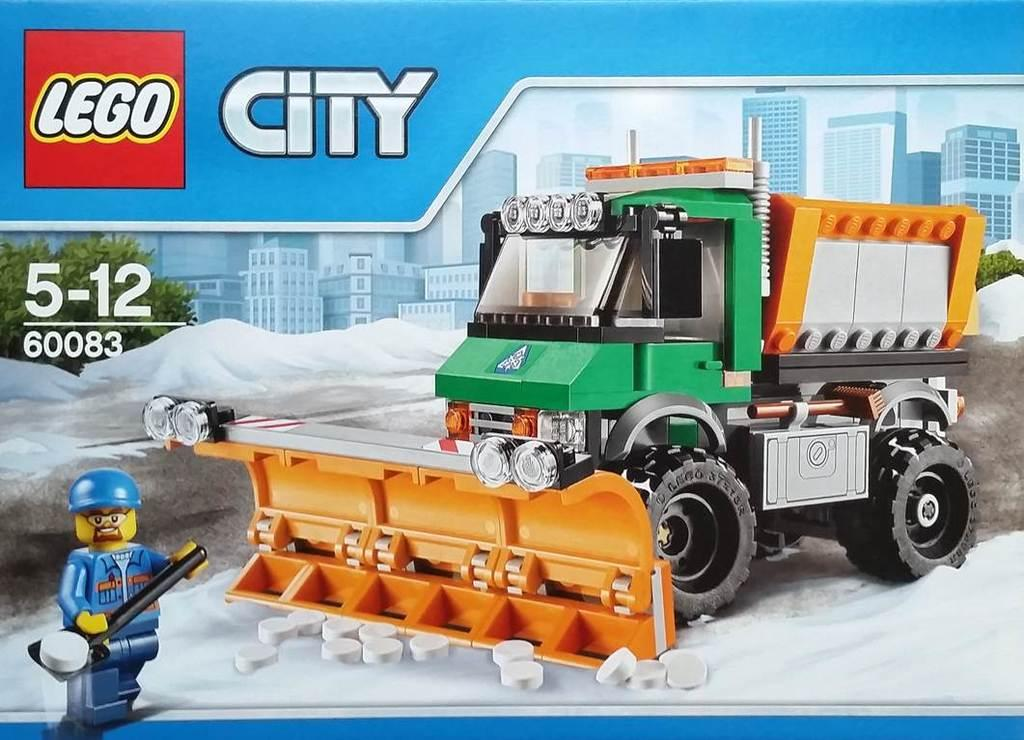What type of visual medium is the image? The image is a poster. What is the main subject depicted on the poster? There is a vehicle depicted on the poster. What other elements can be seen on the poster? There are buildings and trees shown on the poster. Is there any cartoon element present on the poster? Yes, a cartoon character or element is visible on the poster. How much profit does the store on the poster generate? There is no store present on the poster, so it is not possible to determine its profit. 